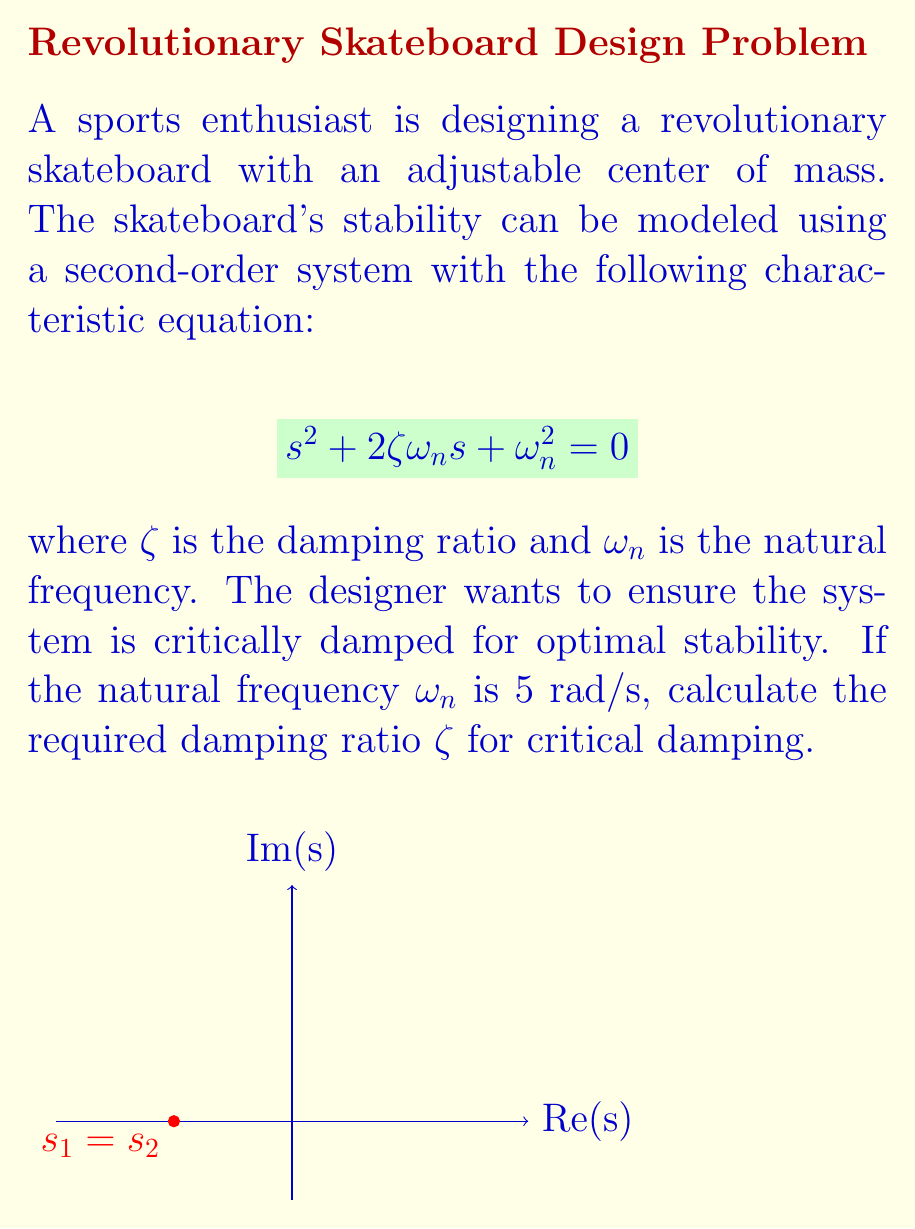Can you solve this math problem? To solve this problem, we need to understand the conditions for critical damping in a second-order system:

1) A system is critically damped when the damping ratio $\zeta = 1$.

2) In a critically damped system, the two poles of the characteristic equation are real and equal.

3) The characteristic equation for a second-order system is:
   $$s^2 + 2\zeta\omega_n s + \omega_n^2 = 0$$

4) For critical damping, this equation should have a double root at $s = -\zeta\omega_n$.

5) Substituting $s = -\zeta\omega_n$ into the characteristic equation:
   $$(-\zeta\omega_n)^2 + 2\zeta\omega_n(-\zeta\omega_n) + \omega_n^2 = 0$$

6) Simplifying:
   $$\zeta^2\omega_n^2 - 2\zeta^2\omega_n^2 + \omega_n^2 = 0$$
   $$\omega_n^2(\zeta^2 - 2\zeta^2 + 1) = 0$$
   $$\omega_n^2(-\zeta^2 + 1) = 0$$

7) Since $\omega_n \neq 0$ (given as 5 rad/s), we can divide both sides by $\omega_n^2$:
   $$-\zeta^2 + 1 = 0$$
   $$\zeta^2 = 1$$
   $$\zeta = 1$$ (taking the positive root as damping ratio is always positive)

8) Therefore, for critical damping, the damping ratio $\zeta$ must equal 1, regardless of the value of $\omega_n$.
Answer: $\zeta = 1$ 